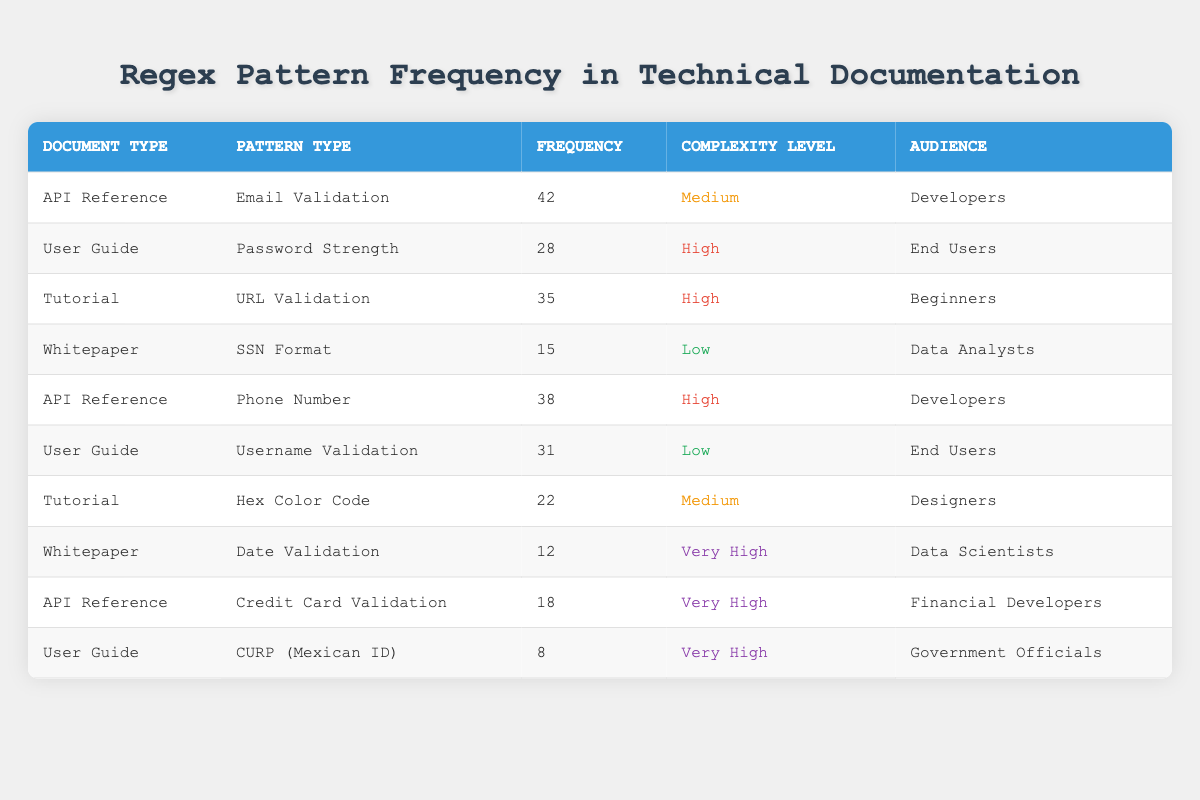What is the frequency of the "Email Validation" regex pattern? The table shows the row with "Email Validation" under the "Pattern Type" column, which indicates the corresponding frequency. In that row, the frequency listed is 42.
Answer: 42 Which document type has the highest frequency of regex patterns? To find the highest frequency, we compare the frequency values across all document types. "API Reference" has two entries with frequencies 42 (Email Validation) and 38 (Phone Number) totaling 80, while other document types do not exceed this total. Therefore, "API Reference" is the document type with the highest total frequency.
Answer: API Reference How many regex patterns in the "User Guide" have a high complexity level? The "User Guide" has two regex patterns listed: Password Strength with high complexity (28) and Username Validation with low complexity (31). Therefore, only 1 regex pattern has a high complexity.
Answer: 1 What is the total frequency of all regex patterns classified as "Very High" complexity? First, identify the patterns classified as "Very High": Date Validation (12), Credit Card Validation (18), and CURP (8). Their total frequency is calculated as 12 + 18 + 8 = 38.
Answer: 38 Does the "Tutorial" have any regex patterns with a low complexity level? Looking at the "Tutorial" entries, we find URL Validation (high) and Hex Color Code (medium), meaning there are no patterns marked as low complexity.
Answer: No What is the average frequency of regex patterns across all document types listed in the table? To find the average frequency: sum up the frequencies: 42 + 28 + 35 + 15 + 38 + 31 + 22 + 12 + 18 + 8 =  338. There are 10 document entries, so the average is 338 / 10 = 33.8.
Answer: 33.8 Which regex pattern type has the lowest frequency of occurrence in the table? By examining the frequency column, the "CURP (Mexican ID)" pattern in the "User Guide" shows a frequency of 8, which is the lowest compared to other frequency values.
Answer: CURP (Mexican ID) Is there any regex pattern in the "Whitepaper" with a complexity level of low? There are two entries in the "Whitepaper": SSN Format (low, frequency 15) and Date Validation (very high, frequency 12). Since SSN Format has a low complexity, the answer is yes.
Answer: Yes 